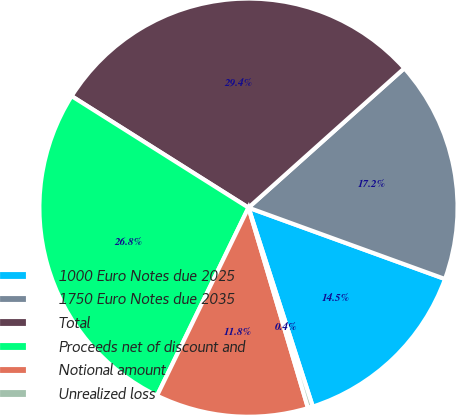Convert chart. <chart><loc_0><loc_0><loc_500><loc_500><pie_chart><fcel>1000 Euro Notes due 2025<fcel>1750 Euro Notes due 2035<fcel>Total<fcel>Proceeds net of discount and<fcel>Notional amount<fcel>Unrealized loss<nl><fcel>14.48%<fcel>17.16%<fcel>29.43%<fcel>26.75%<fcel>11.8%<fcel>0.38%<nl></chart> 